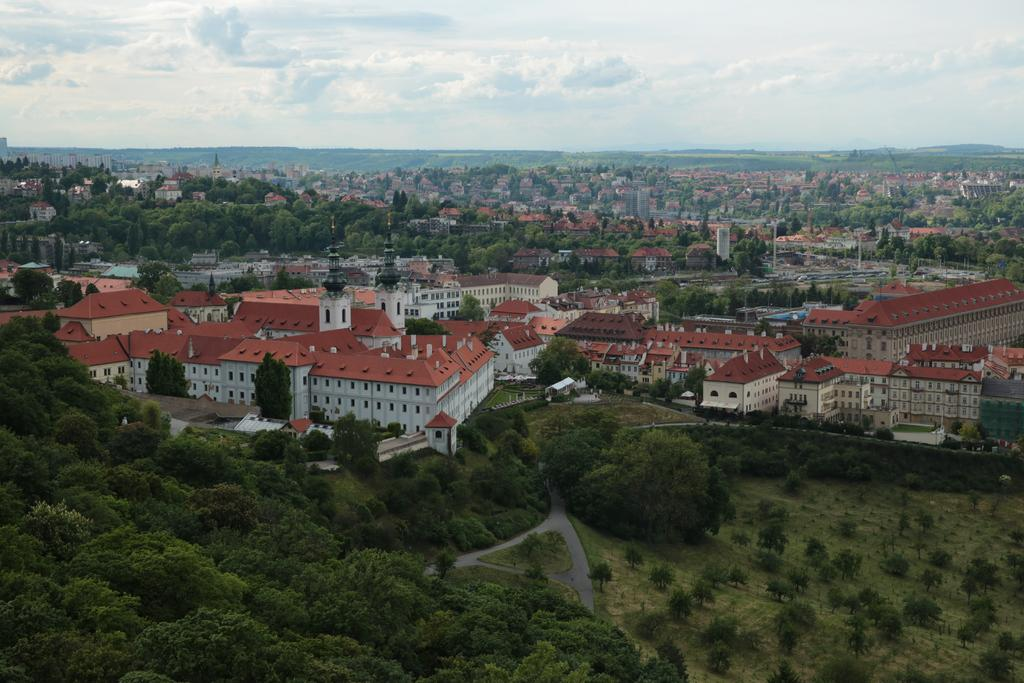What is the possible location from where the image was taken? The image might be taken from outside of the city. What type of vegetation can be seen in the image? There are trees and plants in the image. What man-made structures are visible in the image? There are buildings and houses in the image. What natural feature can be seen in the image? There is a mountain in the image. What is visible at the top of the image? The sky is visible at the top of the image. What type of question is being asked in the image? There is no question present in the image; it is a visual representation of a scene. How many items are on a list that is not visible in the image? There is no list present in the image, so it is impossible to determine the number of items on it. 